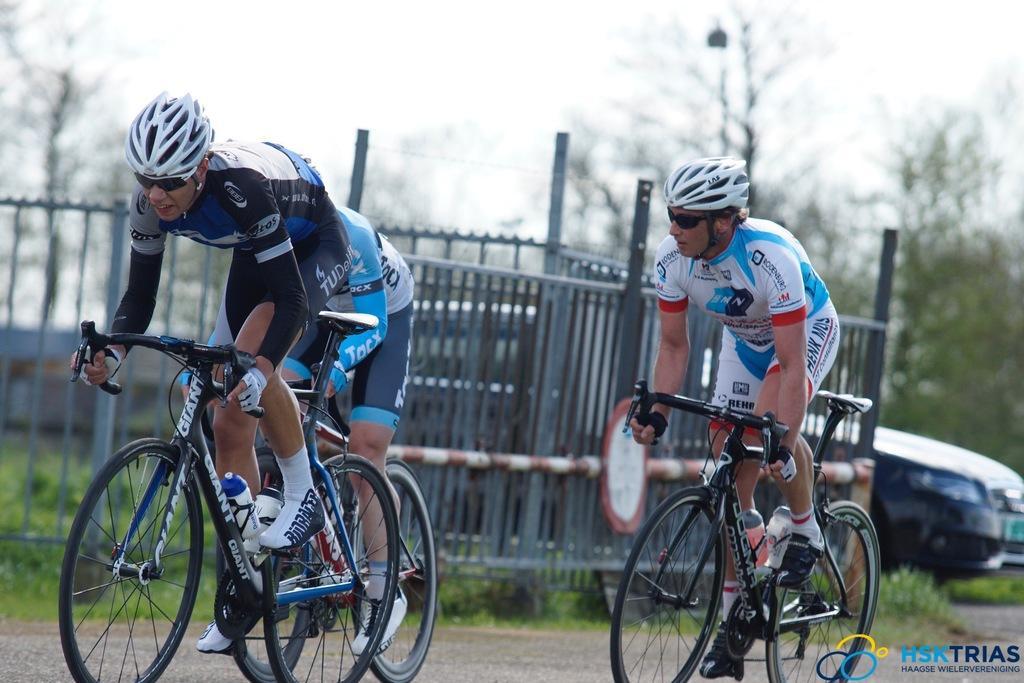Can you describe this image briefly? In this image there are three men cycling on a road, in the background there is a fencing, car, trees, in the bottom right there is a text. 